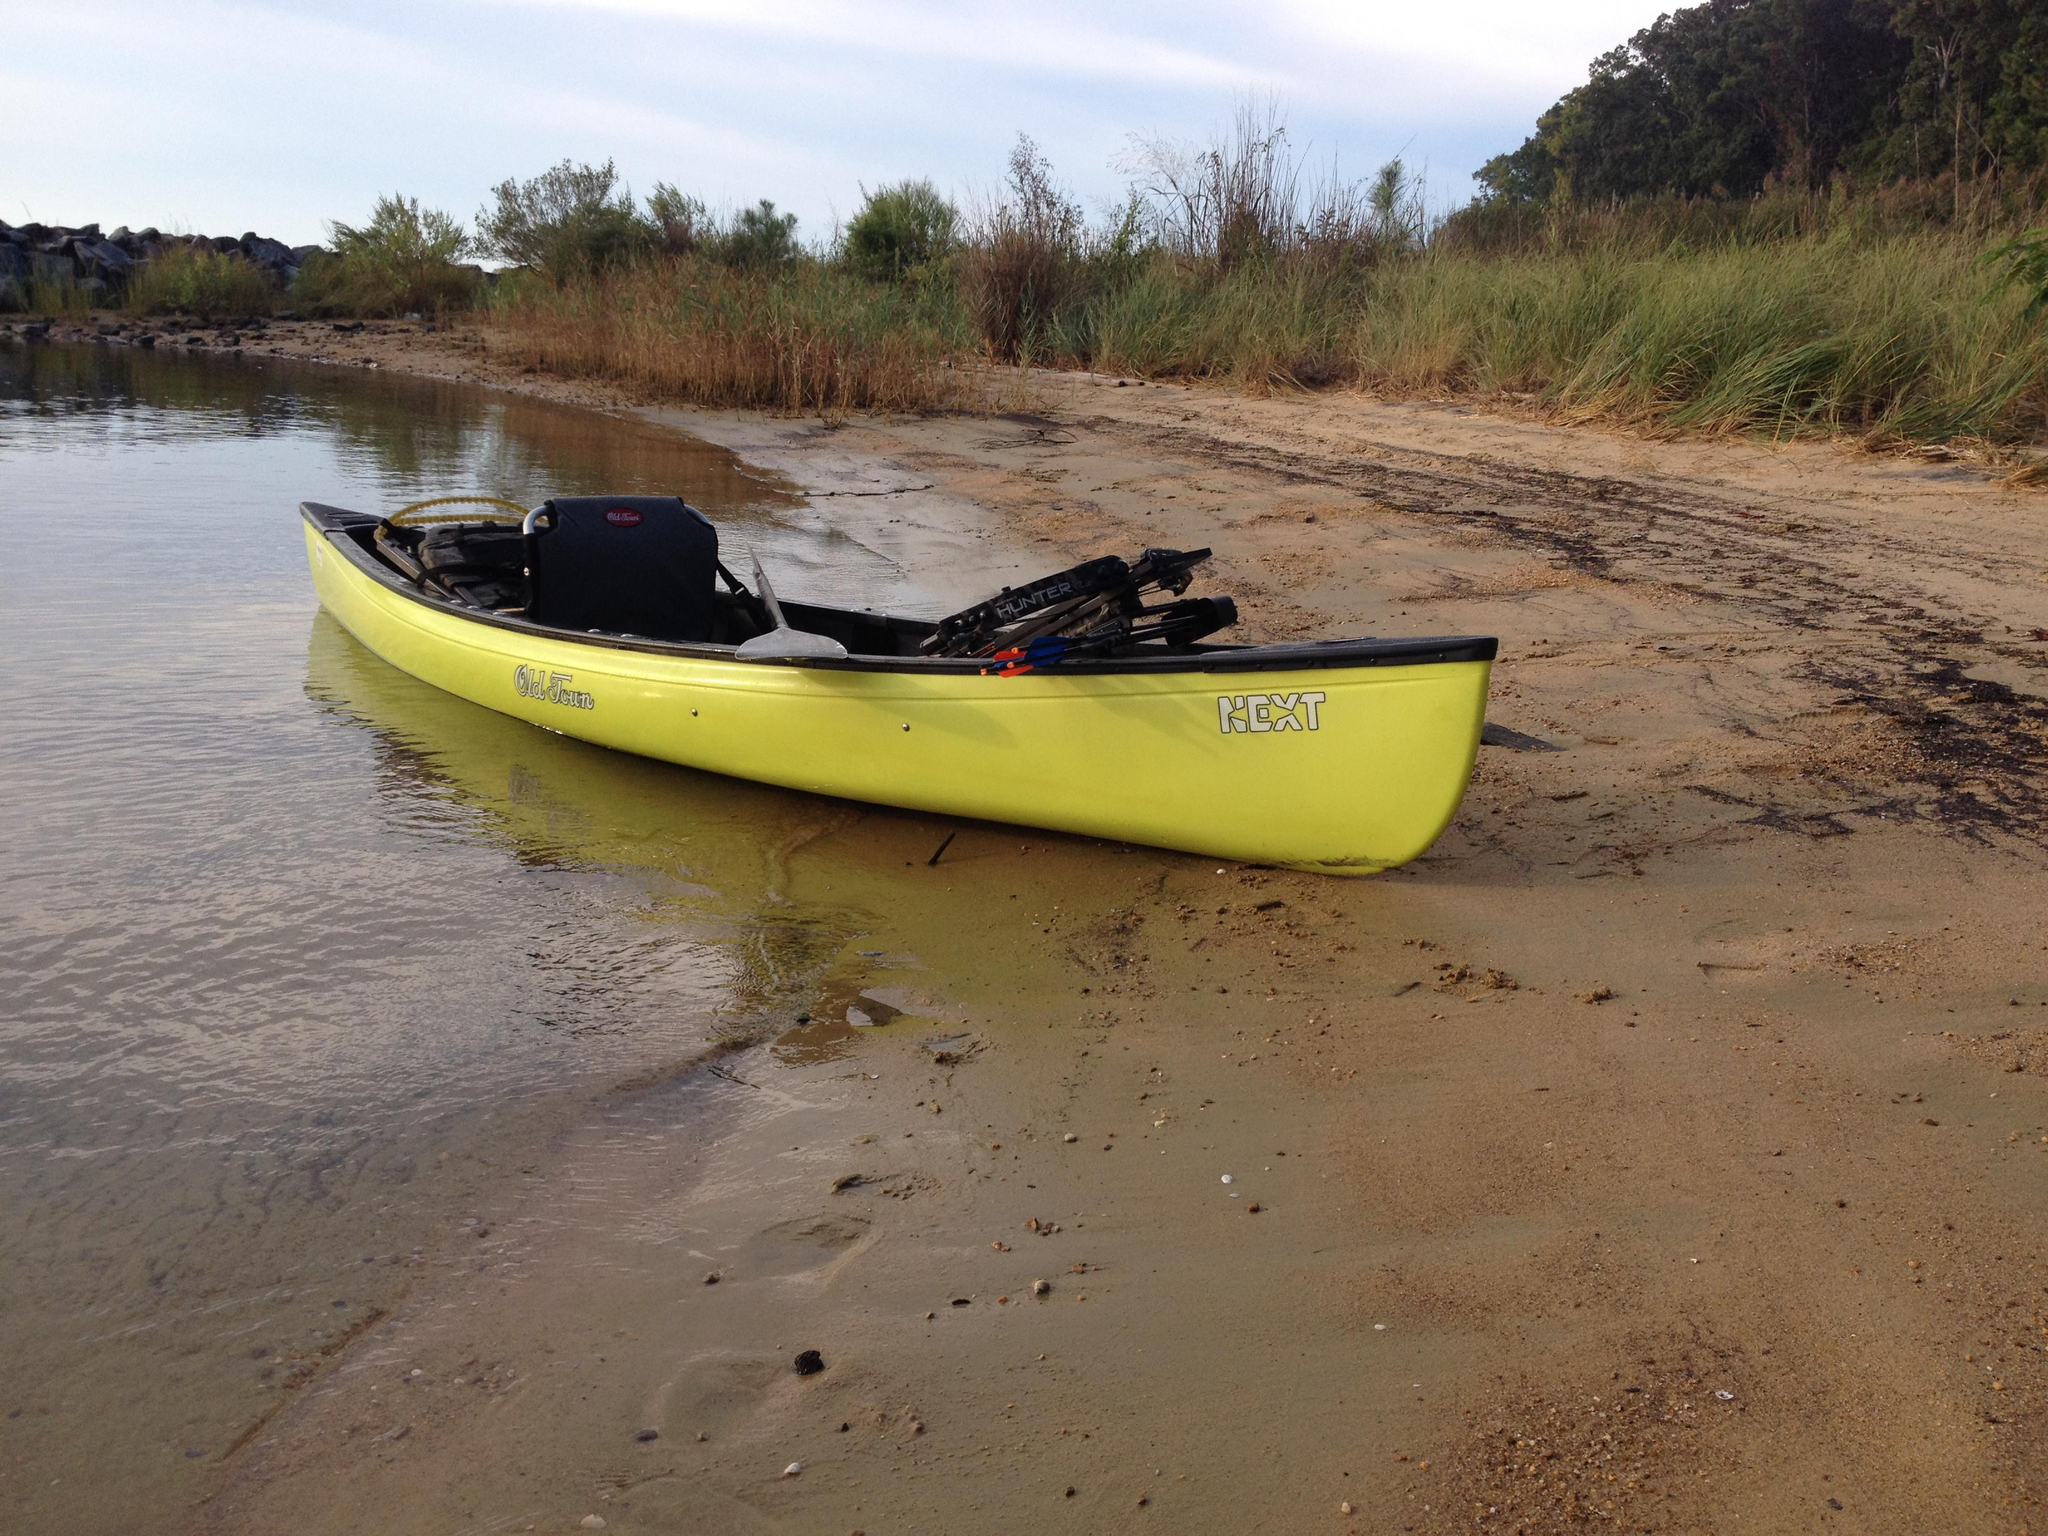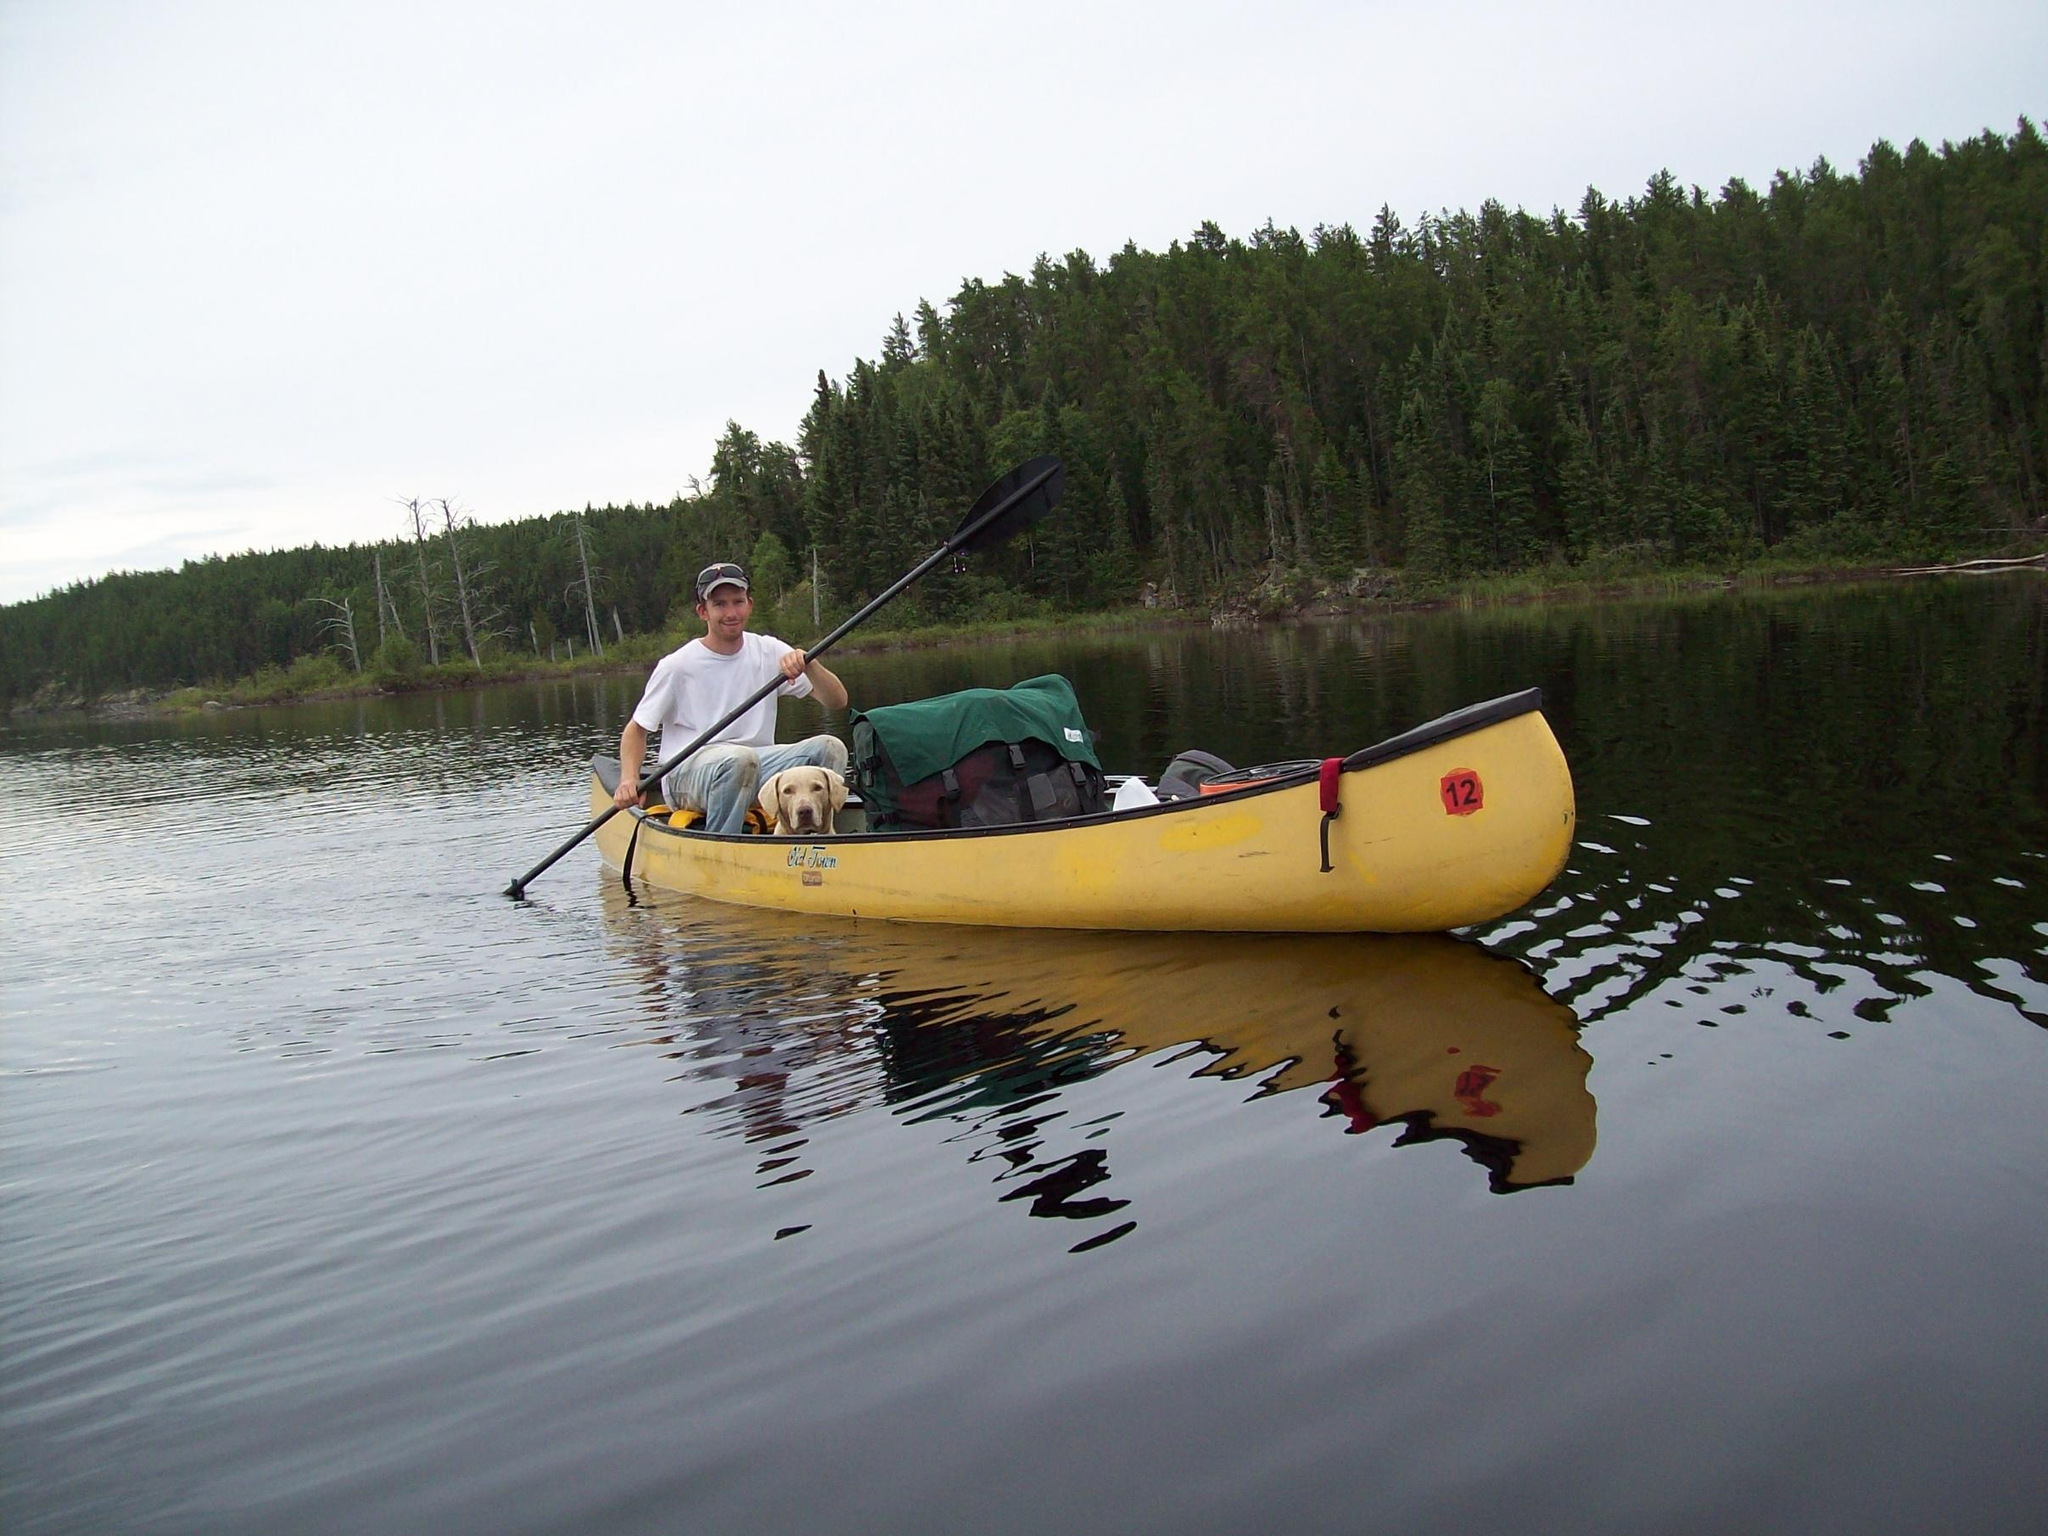The first image is the image on the left, the second image is the image on the right. Evaluate the accuracy of this statement regarding the images: "In one image, a man in a canoe is holding an oar and wearing a life vest and hat.". Is it true? Answer yes or no. No. The first image is the image on the left, the second image is the image on the right. For the images displayed, is the sentence "A person is paddling a canoe diagonally to the left in the left image." factually correct? Answer yes or no. No. 